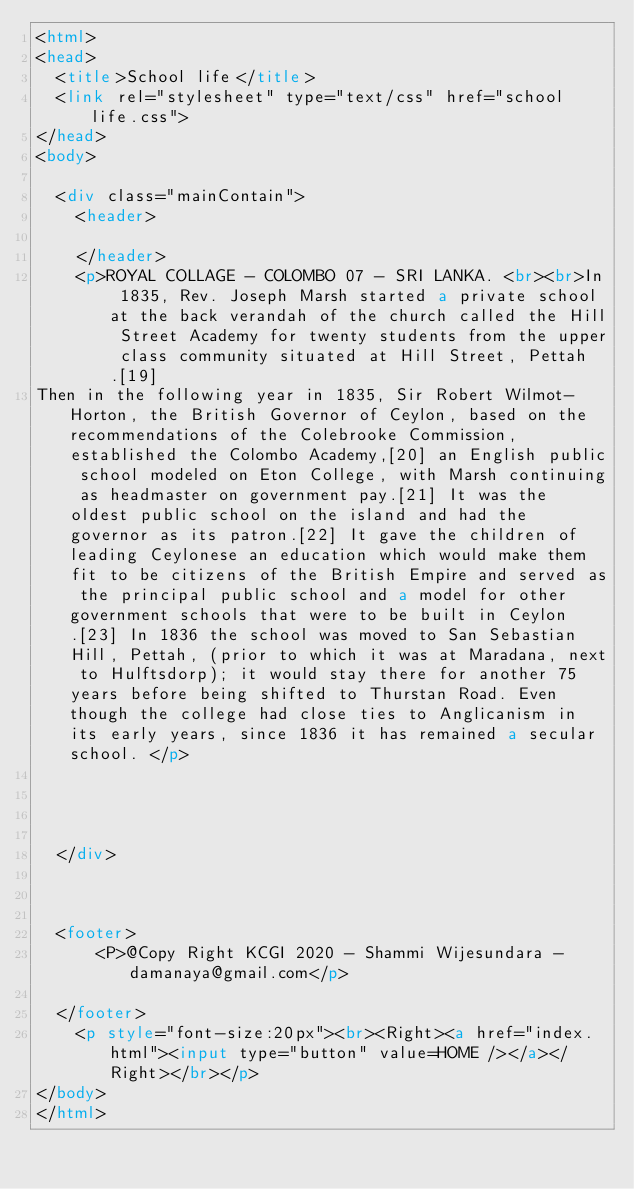<code> <loc_0><loc_0><loc_500><loc_500><_HTML_><html>
<head>
	<title>School life</title>
	<link rel="stylesheet" type="text/css" href="school life.css">
</head>
<body>

	<div class="mainContain">
		<header>

		</header>
		<p>ROYAL COLLAGE - COLOMBO 07 - SRI LANKA. <br><br>In 1835, Rev. Joseph Marsh started a private school at the back verandah of the church called the Hill Street Academy for twenty students from the upper class community situated at Hill Street, Pettah.[19]
Then in the following year in 1835, Sir Robert Wilmot-Horton, the British Governor of Ceylon, based on the recommendations of the Colebrooke Commission, established the Colombo Academy,[20] an English public school modeled on Eton College, with Marsh continuing as headmaster on government pay.[21] It was the oldest public school on the island and had the governor as its patron.[22] It gave the children of leading Ceylonese an education which would make them fit to be citizens of the British Empire and served as the principal public school and a model for other government schools that were to be built in Ceylon.[23] In 1836 the school was moved to San Sebastian Hill, Pettah, (prior to which it was at Maradana, next to Hulftsdorp); it would stay there for another 75 years before being shifted to Thurstan Road. Even though the college had close ties to Anglicanism in its early years, since 1836 it has remained a secular school. </p>




	</div>



	<footer>
			<P>@Copy Right KCGI 2020 - Shammi Wijesundara - damanaya@gmail.com</p>

	</footer>
		<p style="font-size:20px"><br><Right><a href="index.html"><input type="button" value=HOME /></a></Right></br></p>
</body>
</html>
</code> 